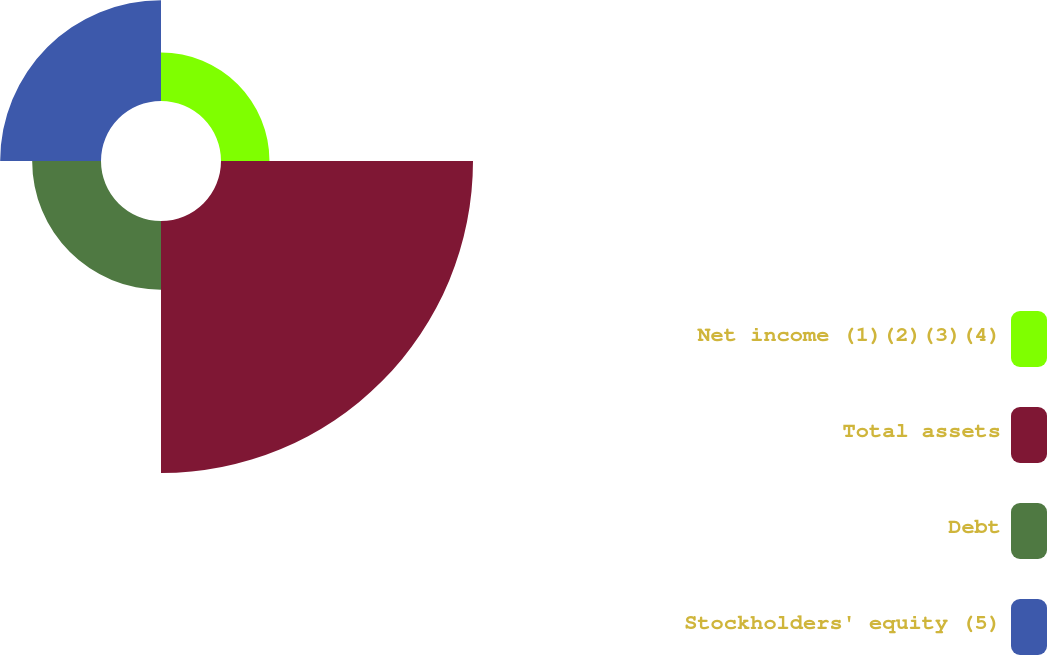Convert chart to OTSL. <chart><loc_0><loc_0><loc_500><loc_500><pie_chart><fcel>Net income (1)(2)(3)(4)<fcel>Total assets<fcel>Debt<fcel>Stockholders' equity (5)<nl><fcel>10.31%<fcel>53.6%<fcel>14.64%<fcel>21.45%<nl></chart> 